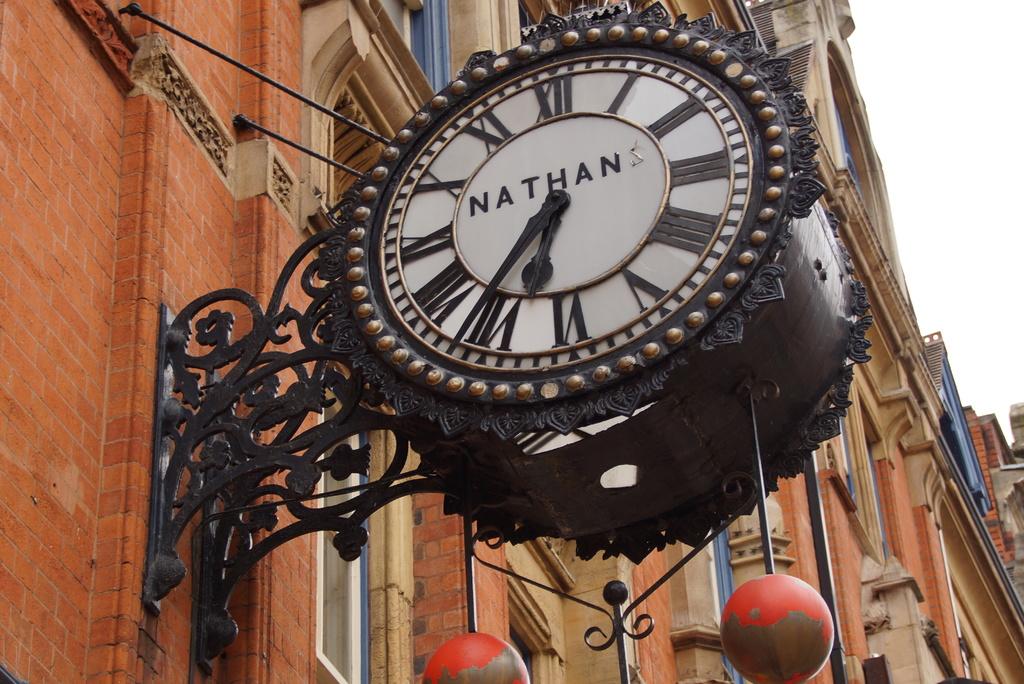What type of numbers are on the clock?
Keep it short and to the point. Roman numerals. 